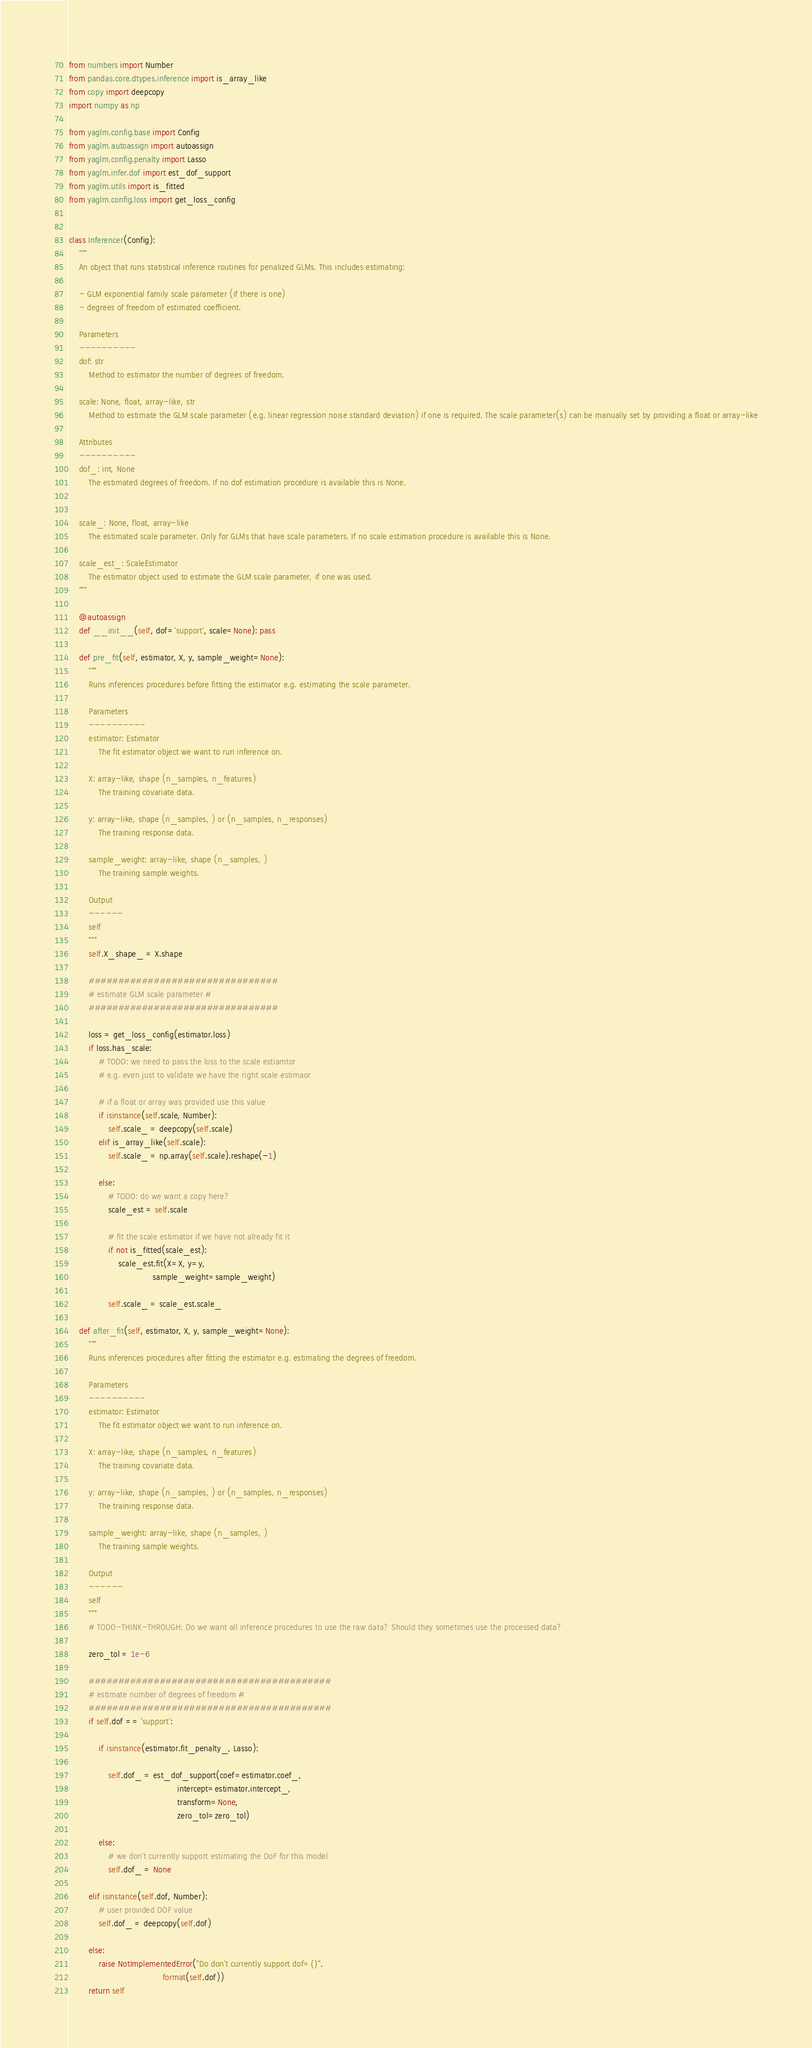Convert code to text. <code><loc_0><loc_0><loc_500><loc_500><_Python_>from numbers import Number
from pandas.core.dtypes.inference import is_array_like
from copy import deepcopy
import numpy as np

from yaglm.config.base import Config
from yaglm.autoassign import autoassign
from yaglm.config.penalty import Lasso
from yaglm.infer.dof import est_dof_support
from yaglm.utils import is_fitted
from yaglm.config.loss import get_loss_config


class Inferencer(Config):
    """
    An object that runs statistical inference routines for penalized GLMs. This includes estimating:

    - GLM exponential family scale parameter (if there is one)
    - degrees of freedom of estimated coefficient.

    Parameters
    ----------
    dof: str
        Method to estimator the number of degrees of freedom.

    scale: None, float, array-like, str
        Method to estimate the GLM scale parameter (e.g. linear regression noise standard deviation) if one is required. The scale parameter(s) can be manually set by providing a float or array-like

    Attributes
    ----------
    dof_: int, None
        The estimated degrees of freedom. If no dof estimation procedure is available this is None.


    scale_: None, float, array-like
        The estimated scale parameter. Only for GLMs that have scale parameters. If no scale estimation procedure is available this is None.

    scale_est_: ScaleEstimator
        The estimator object used to estimate the GLM scale parameter, if one was used.
    """

    @autoassign
    def __init__(self, dof='support', scale=None): pass

    def pre_fit(self, estimator, X, y, sample_weight=None):
        """
        Runs inferences procedures before fitting the estimator e.g. estimating the scale parameter.

        Parameters
        ----------
        estimator: Estimator
            The fit estimator object we want to run inference on.

        X: array-like, shape (n_samples, n_features)
            The training covariate data.

        y: array-like, shape (n_samples, ) or (n_samples, n_responses)
            The training response data.

        sample_weight: array-like, shape (n_samples, )
            The training sample weights.

        Output
        ------
        self
        """
        self.X_shape_ = X.shape

        ################################
        # estimate GLM scale parameter #
        ################################

        loss = get_loss_config(estimator.loss)
        if loss.has_scale:
            # TODO: we need to pass the loss to the scale estiamtor
            # e.g. even just to validate we have the right scale estimaor

            # if a float or array was provided use this value
            if isinstance(self.scale, Number):
                self.scale_ = deepcopy(self.scale)
            elif is_array_like(self.scale):
                self.scale_ = np.array(self.scale).reshape(-1)

            else:
                # TODO: do we want a copy here?
                scale_est = self.scale

                # fit the scale estimator if we have not already fit it
                if not is_fitted(scale_est):
                    scale_est.fit(X=X, y=y,
                                  sample_weight=sample_weight)

                self.scale_ = scale_est.scale_

    def after_fit(self, estimator, X, y, sample_weight=None):
        """
        Runs inferences procedures after fitting the estimator e.g. estimating the degrees of freedom.

        Parameters
        ----------
        estimator: Estimator
            The fit estimator object we want to run inference on.

        X: array-like, shape (n_samples, n_features)
            The training covariate data.

        y: array-like, shape (n_samples, ) or (n_samples, n_responses)
            The training response data.

        sample_weight: array-like, shape (n_samples, )
            The training sample weights.

        Output
        ------
        self
        """
        # TODO-THINK-THROUGH: Do we want all inference procedures to use the raw data? Should they sometimes use the processed data?

        zero_tol = 1e-6

        #########################################
        # estimate number of degrees of freedom #
        #########################################
        if self.dof == 'support':

            if isinstance(estimator.fit_penalty_, Lasso):

                self.dof_ = est_dof_support(coef=estimator.coef_,
                                            intercept=estimator.intercept_,
                                            transform=None,
                                            zero_tol=zero_tol)

            else:
                # we don't currently support estimating the DoF for this model
                self.dof_ = None

        elif isinstance(self.dof, Number):
            # user provided DOF value
            self.dof_ = deepcopy(self.dof)

        else:
            raise NotImplementedError("Do don't currently support dof={}".
                                      format(self.dof))
        return self
</code> 